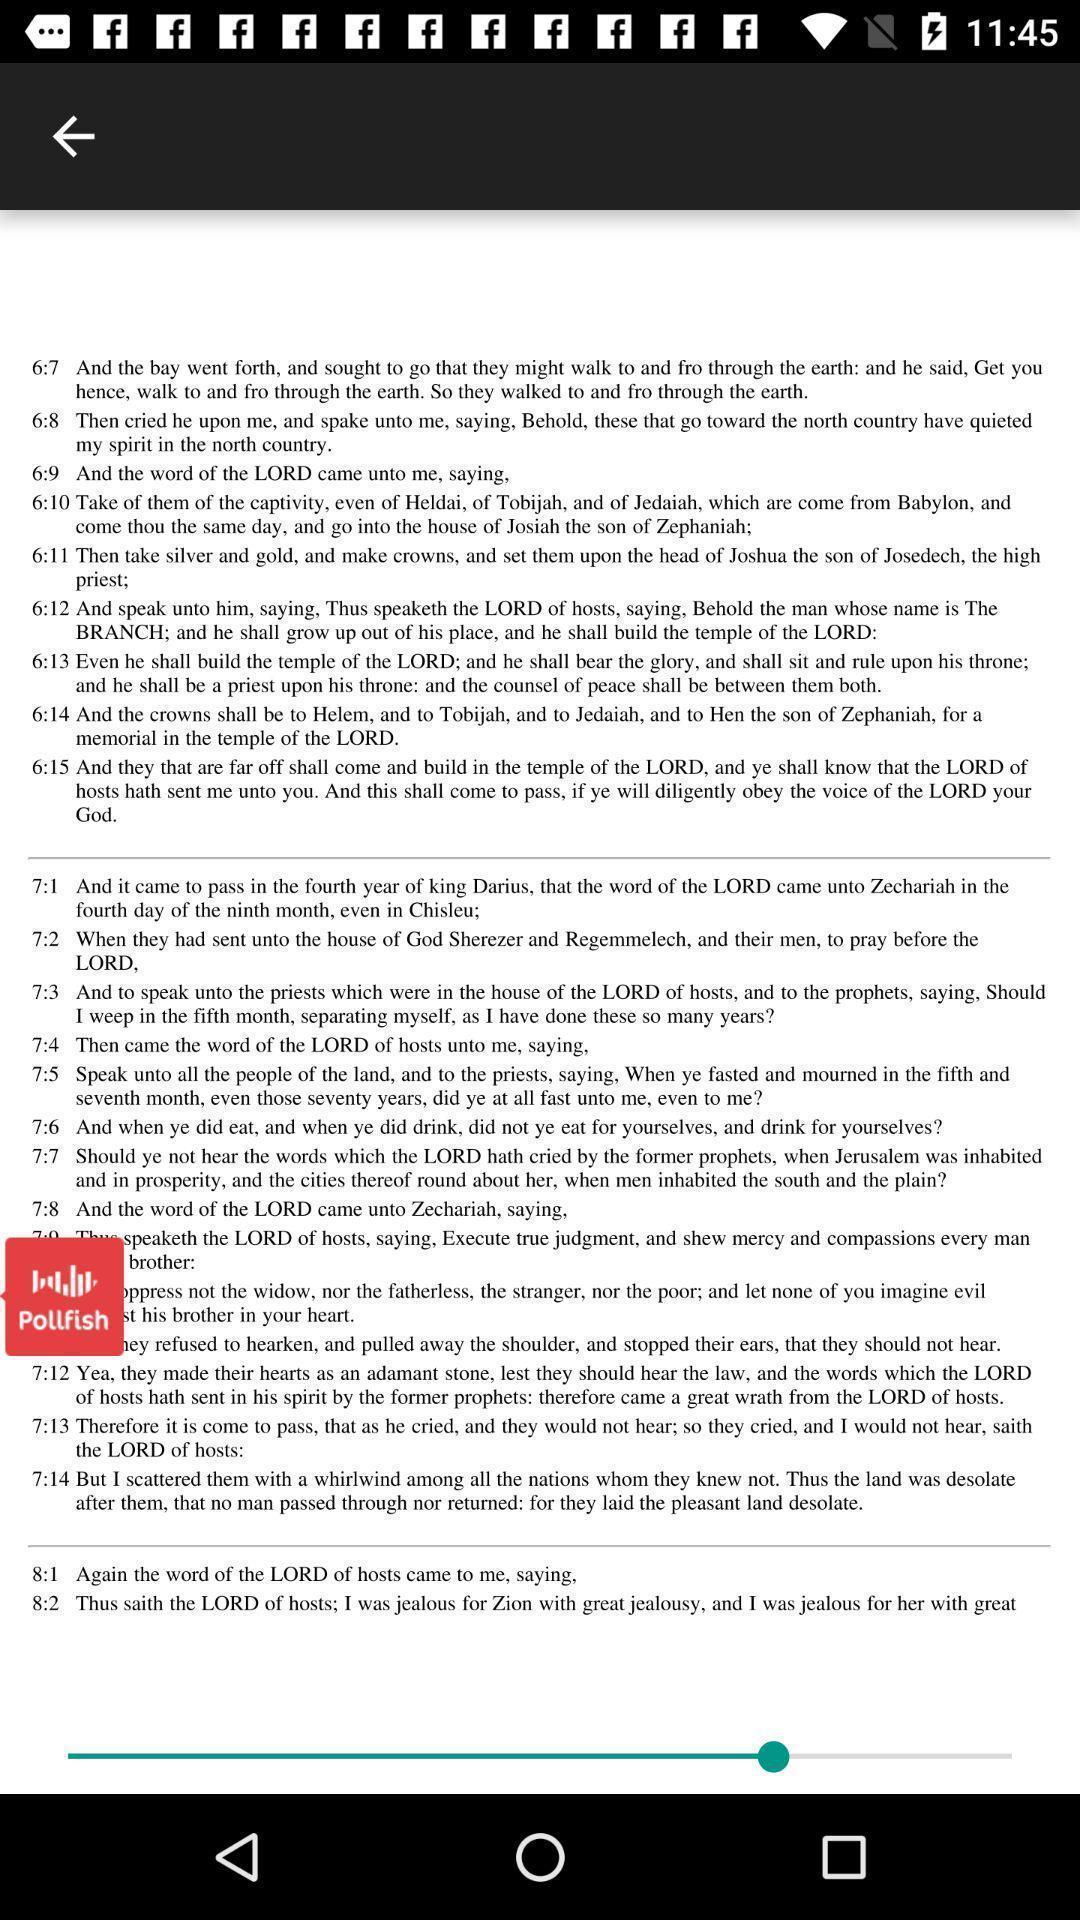What can you discern from this picture? Verses page of a bible app. 